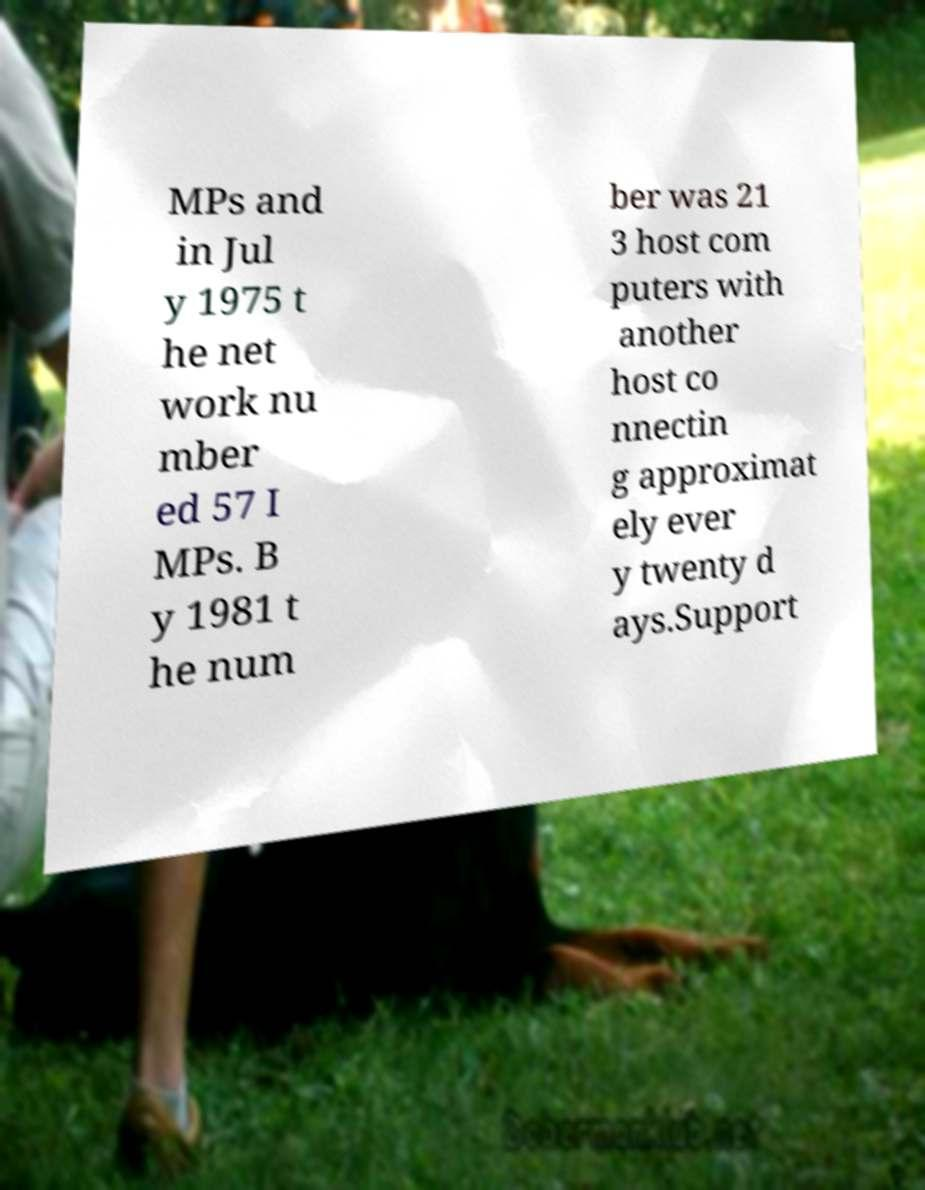Could you extract and type out the text from this image? MPs and in Jul y 1975 t he net work nu mber ed 57 I MPs. B y 1981 t he num ber was 21 3 host com puters with another host co nnectin g approximat ely ever y twenty d ays.Support 